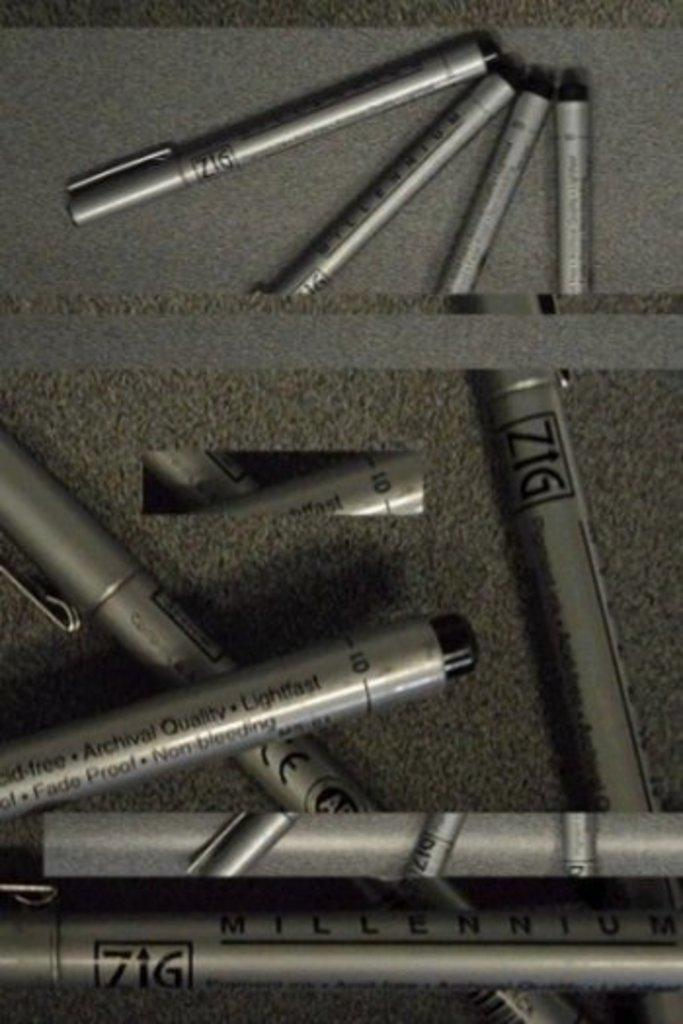What types of pens are visible in the image? There are black and ash color pens in the image. What is the color of the surface on which the pens are placed? The pens are on an ash color surface. What type of seashore can be seen in the image? There is no seashore present in the image; it features black and ash color pens on an ash color surface. How does the concept of death relate to the image? The image does not depict or reference any aspect of death. 